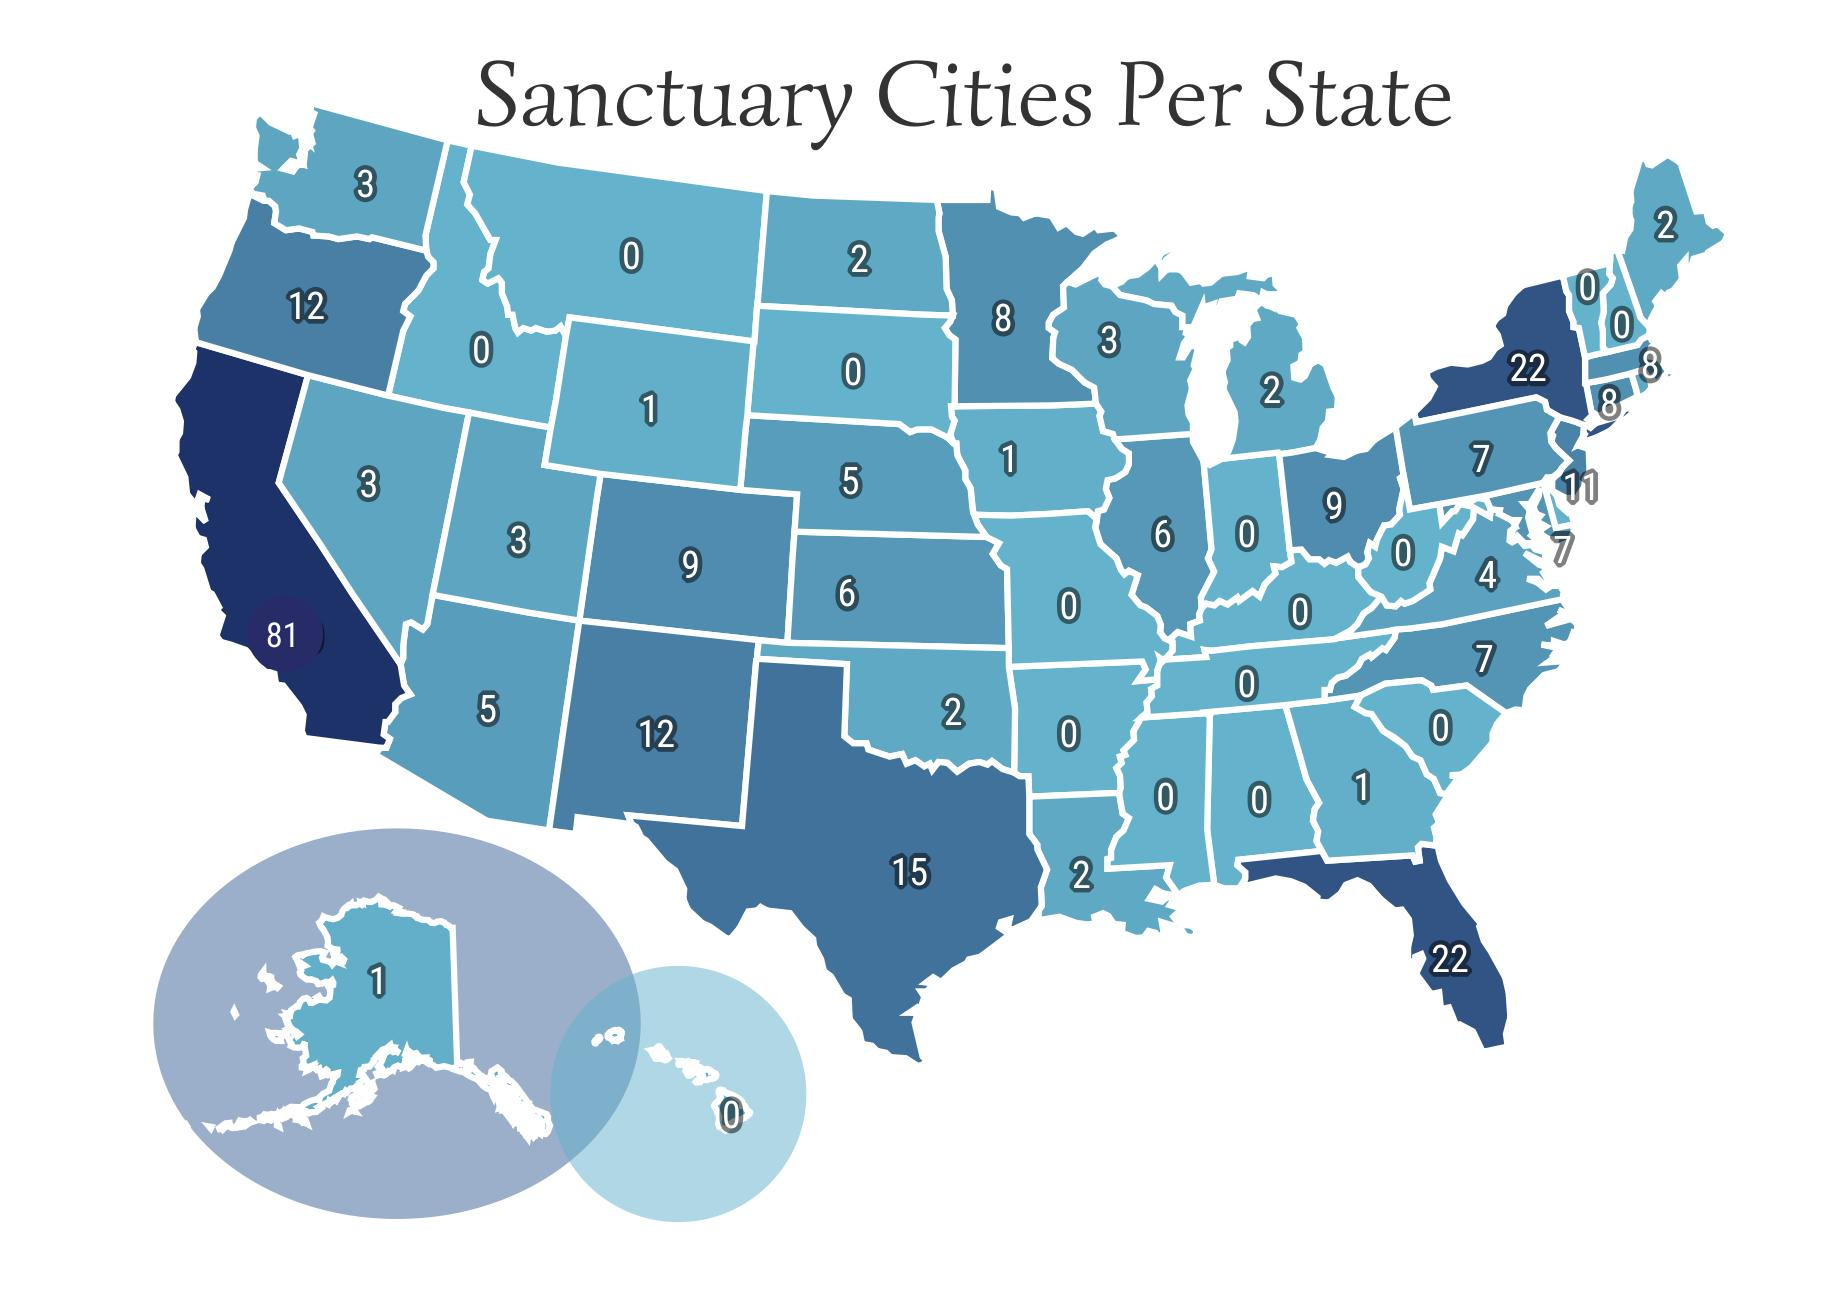Mention a couple of crucial points in this snapshot. California and New Jersey are the states that have the second highest number of sanctuary cities. There is only one sanctuary city per state, with the second lowest number being 1. According to the latest data, there are currently 15 sanctuary cities per state, with the third highest number of sanctuary cities. Seventeen states have more than 10 sanctuary cities. According to available information, three states have more than 20 sanctuary cities. 